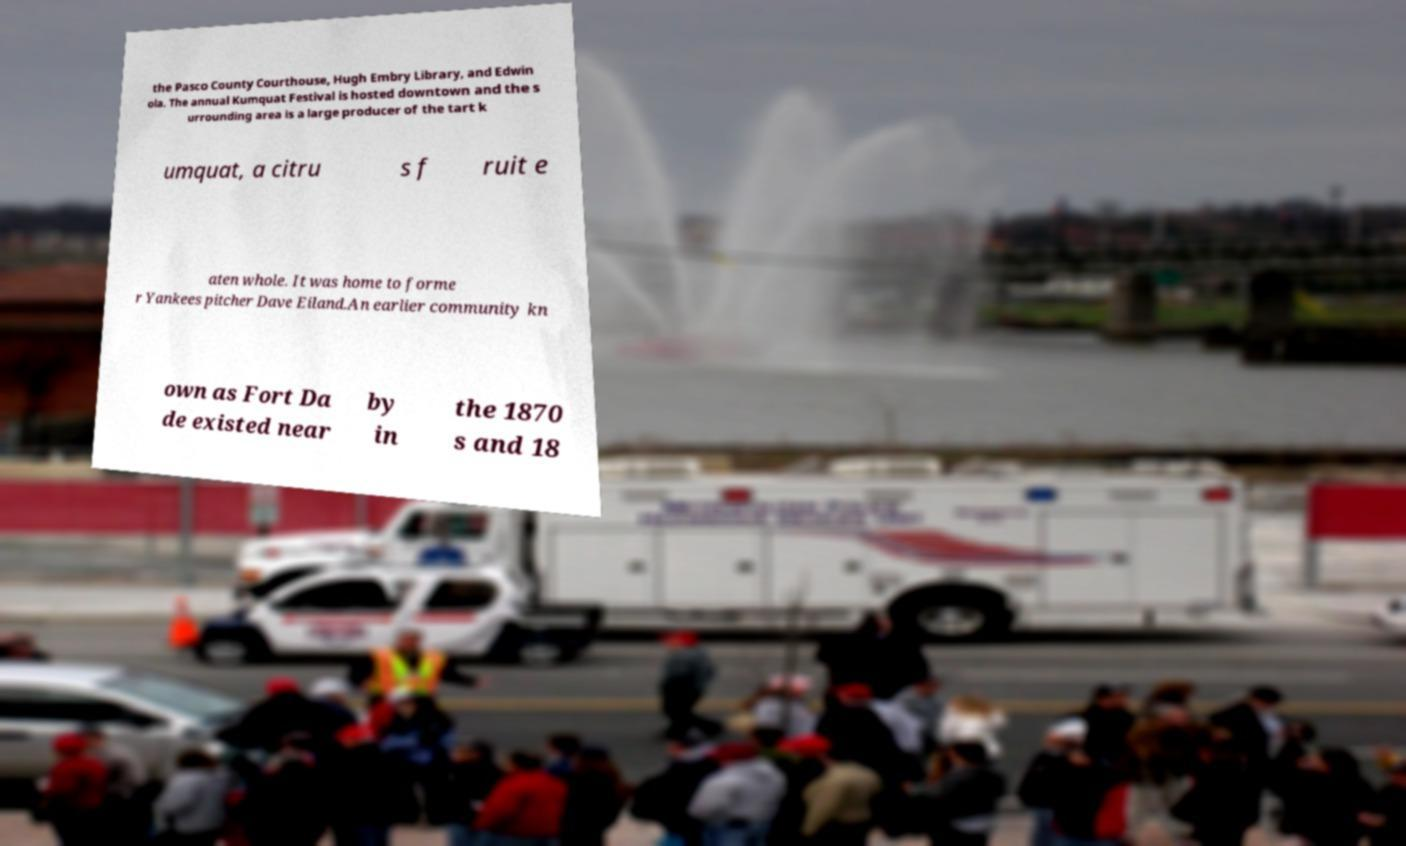For documentation purposes, I need the text within this image transcribed. Could you provide that? the Pasco County Courthouse, Hugh Embry Library, and Edwin ola. The annual Kumquat Festival is hosted downtown and the s urrounding area is a large producer of the tart k umquat, a citru s f ruit e aten whole. It was home to forme r Yankees pitcher Dave Eiland.An earlier community kn own as Fort Da de existed near by in the 1870 s and 18 